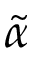Convert formula to latex. <formula><loc_0><loc_0><loc_500><loc_500>\tilde { \alpha }</formula> 